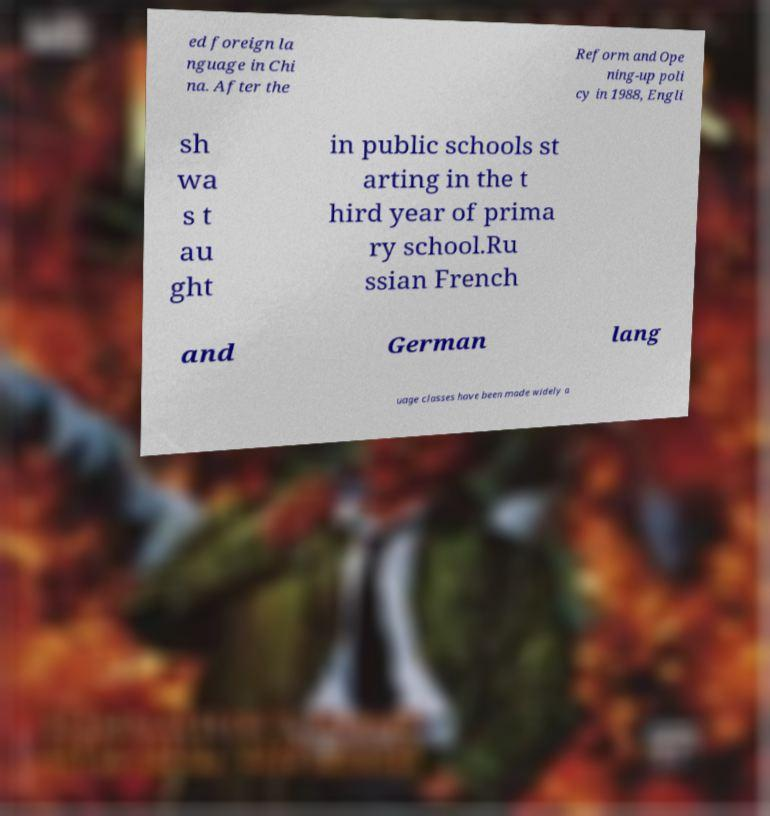I need the written content from this picture converted into text. Can you do that? ed foreign la nguage in Chi na. After the Reform and Ope ning-up poli cy in 1988, Engli sh wa s t au ght in public schools st arting in the t hird year of prima ry school.Ru ssian French and German lang uage classes have been made widely a 